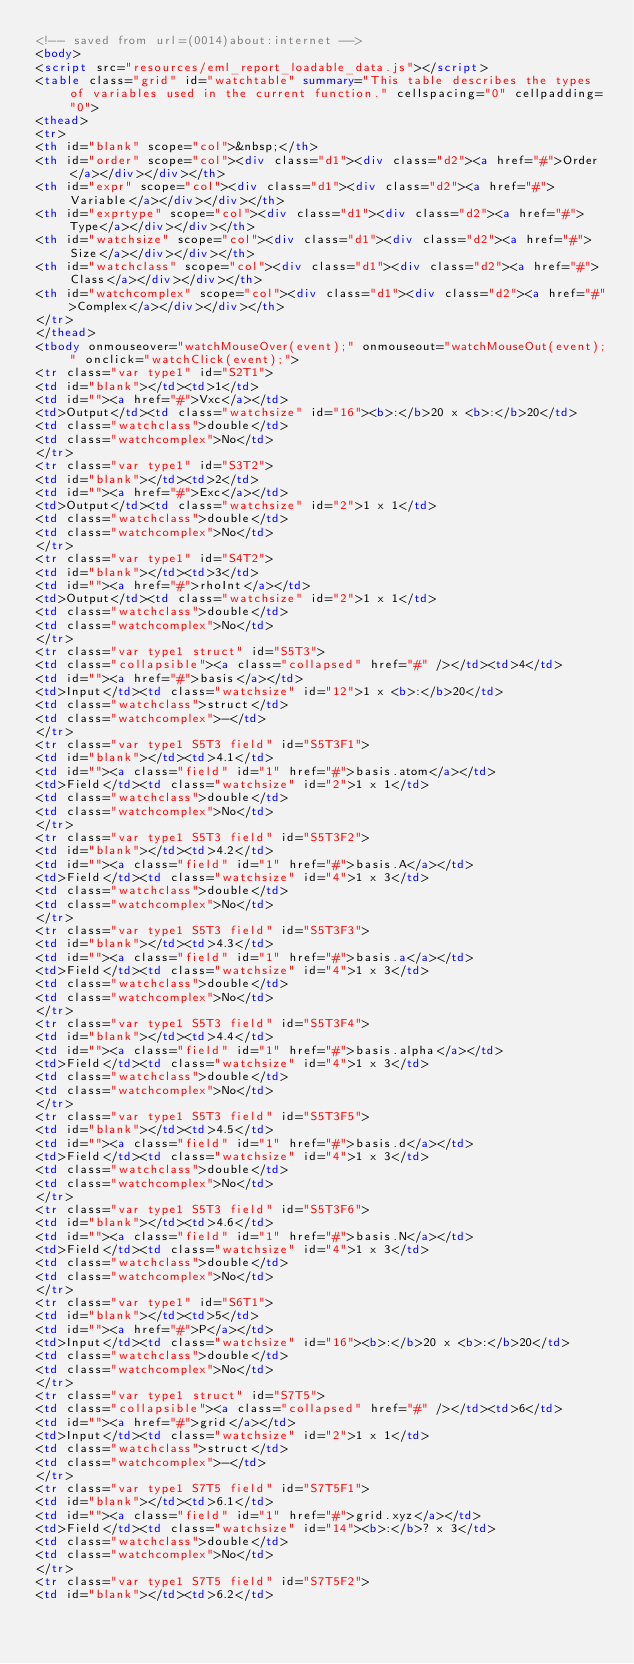<code> <loc_0><loc_0><loc_500><loc_500><_HTML_><!-- saved from url=(0014)about:internet -->
<body>
<script src="resources/eml_report_loadable_data.js"></script>
<table class="grid" id="watchtable" summary="This table describes the types of variables used in the current function." cellspacing="0" cellpadding="0">
<thead>
<tr>
<th id="blank" scope="col">&nbsp;</th>
<th id="order" scope="col"><div class="d1"><div class="d2"><a href="#">Order</a></div></div></th>
<th id="expr" scope="col"><div class="d1"><div class="d2"><a href="#">Variable</a></div></div></th>
<th id="exprtype" scope="col"><div class="d1"><div class="d2"><a href="#">Type</a></div></div></th>
<th id="watchsize" scope="col"><div class="d1"><div class="d2"><a href="#">Size</a></div></div></th>
<th id="watchclass" scope="col"><div class="d1"><div class="d2"><a href="#">Class</a></div></div></th>
<th id="watchcomplex" scope="col"><div class="d1"><div class="d2"><a href="#">Complex</a></div></div></th>
</tr>
</thead>
<tbody onmouseover="watchMouseOver(event);" onmouseout="watchMouseOut(event);" onclick="watchClick(event);">
<tr class="var type1" id="S2T1">
<td id="blank"></td><td>1</td>
<td id=""><a href="#">Vxc</a></td>
<td>Output</td><td class="watchsize" id="16"><b>:</b>20 x <b>:</b>20</td>
<td class="watchclass">double</td>
<td class="watchcomplex">No</td>
</tr>
<tr class="var type1" id="S3T2">
<td id="blank"></td><td>2</td>
<td id=""><a href="#">Exc</a></td>
<td>Output</td><td class="watchsize" id="2">1 x 1</td>
<td class="watchclass">double</td>
<td class="watchcomplex">No</td>
</tr>
<tr class="var type1" id="S4T2">
<td id="blank"></td><td>3</td>
<td id=""><a href="#">rhoInt</a></td>
<td>Output</td><td class="watchsize" id="2">1 x 1</td>
<td class="watchclass">double</td>
<td class="watchcomplex">No</td>
</tr>
<tr class="var type1 struct" id="S5T3">
<td class="collapsible"><a class="collapsed" href="#" /></td><td>4</td>
<td id=""><a href="#">basis</a></td>
<td>Input</td><td class="watchsize" id="12">1 x <b>:</b>20</td>
<td class="watchclass">struct</td>
<td class="watchcomplex">-</td>
</tr>
<tr class="var type1 S5T3 field" id="S5T3F1">
<td id="blank"></td><td>4.1</td>
<td id=""><a class="field" id="1" href="#">basis.atom</a></td>
<td>Field</td><td class="watchsize" id="2">1 x 1</td>
<td class="watchclass">double</td>
<td class="watchcomplex">No</td>
</tr>
<tr class="var type1 S5T3 field" id="S5T3F2">
<td id="blank"></td><td>4.2</td>
<td id=""><a class="field" id="1" href="#">basis.A</a></td>
<td>Field</td><td class="watchsize" id="4">1 x 3</td>
<td class="watchclass">double</td>
<td class="watchcomplex">No</td>
</tr>
<tr class="var type1 S5T3 field" id="S5T3F3">
<td id="blank"></td><td>4.3</td>
<td id=""><a class="field" id="1" href="#">basis.a</a></td>
<td>Field</td><td class="watchsize" id="4">1 x 3</td>
<td class="watchclass">double</td>
<td class="watchcomplex">No</td>
</tr>
<tr class="var type1 S5T3 field" id="S5T3F4">
<td id="blank"></td><td>4.4</td>
<td id=""><a class="field" id="1" href="#">basis.alpha</a></td>
<td>Field</td><td class="watchsize" id="4">1 x 3</td>
<td class="watchclass">double</td>
<td class="watchcomplex">No</td>
</tr>
<tr class="var type1 S5T3 field" id="S5T3F5">
<td id="blank"></td><td>4.5</td>
<td id=""><a class="field" id="1" href="#">basis.d</a></td>
<td>Field</td><td class="watchsize" id="4">1 x 3</td>
<td class="watchclass">double</td>
<td class="watchcomplex">No</td>
</tr>
<tr class="var type1 S5T3 field" id="S5T3F6">
<td id="blank"></td><td>4.6</td>
<td id=""><a class="field" id="1" href="#">basis.N</a></td>
<td>Field</td><td class="watchsize" id="4">1 x 3</td>
<td class="watchclass">double</td>
<td class="watchcomplex">No</td>
</tr>
<tr class="var type1" id="S6T1">
<td id="blank"></td><td>5</td>
<td id=""><a href="#">P</a></td>
<td>Input</td><td class="watchsize" id="16"><b>:</b>20 x <b>:</b>20</td>
<td class="watchclass">double</td>
<td class="watchcomplex">No</td>
</tr>
<tr class="var type1 struct" id="S7T5">
<td class="collapsible"><a class="collapsed" href="#" /></td><td>6</td>
<td id=""><a href="#">grid</a></td>
<td>Input</td><td class="watchsize" id="2">1 x 1</td>
<td class="watchclass">struct</td>
<td class="watchcomplex">-</td>
</tr>
<tr class="var type1 S7T5 field" id="S7T5F1">
<td id="blank"></td><td>6.1</td>
<td id=""><a class="field" id="1" href="#">grid.xyz</a></td>
<td>Field</td><td class="watchsize" id="14"><b>:</b>? x 3</td>
<td class="watchclass">double</td>
<td class="watchcomplex">No</td>
</tr>
<tr class="var type1 S7T5 field" id="S7T5F2">
<td id="blank"></td><td>6.2</td></code> 